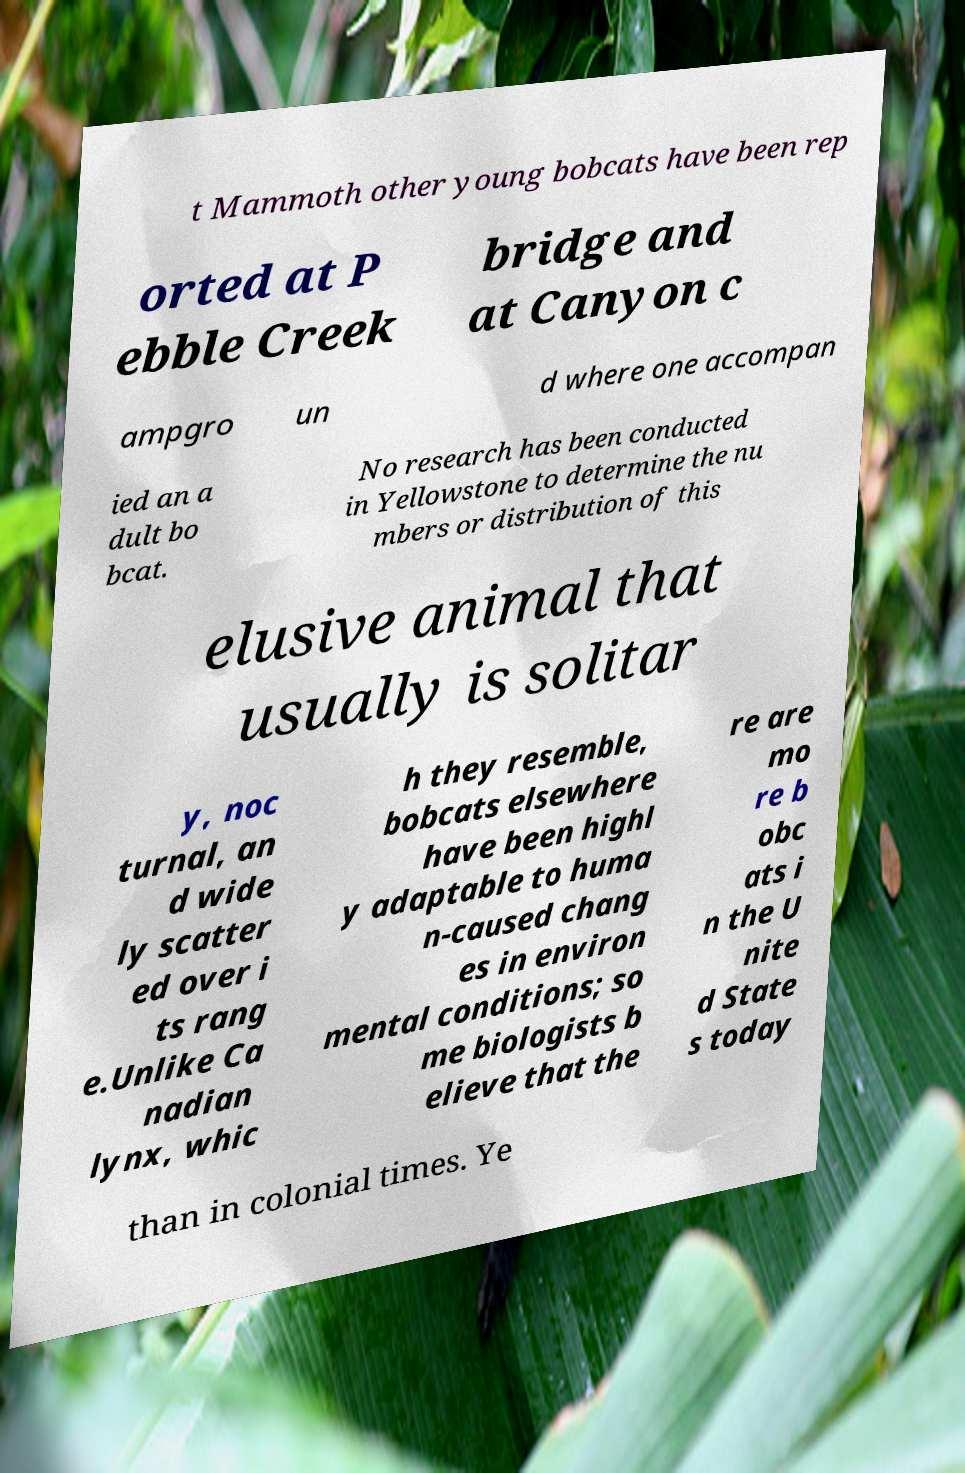Can you read and provide the text displayed in the image?This photo seems to have some interesting text. Can you extract and type it out for me? t Mammoth other young bobcats have been rep orted at P ebble Creek bridge and at Canyon c ampgro un d where one accompan ied an a dult bo bcat. No research has been conducted in Yellowstone to determine the nu mbers or distribution of this elusive animal that usually is solitar y, noc turnal, an d wide ly scatter ed over i ts rang e.Unlike Ca nadian lynx, whic h they resemble, bobcats elsewhere have been highl y adaptable to huma n-caused chang es in environ mental conditions; so me biologists b elieve that the re are mo re b obc ats i n the U nite d State s today than in colonial times. Ye 